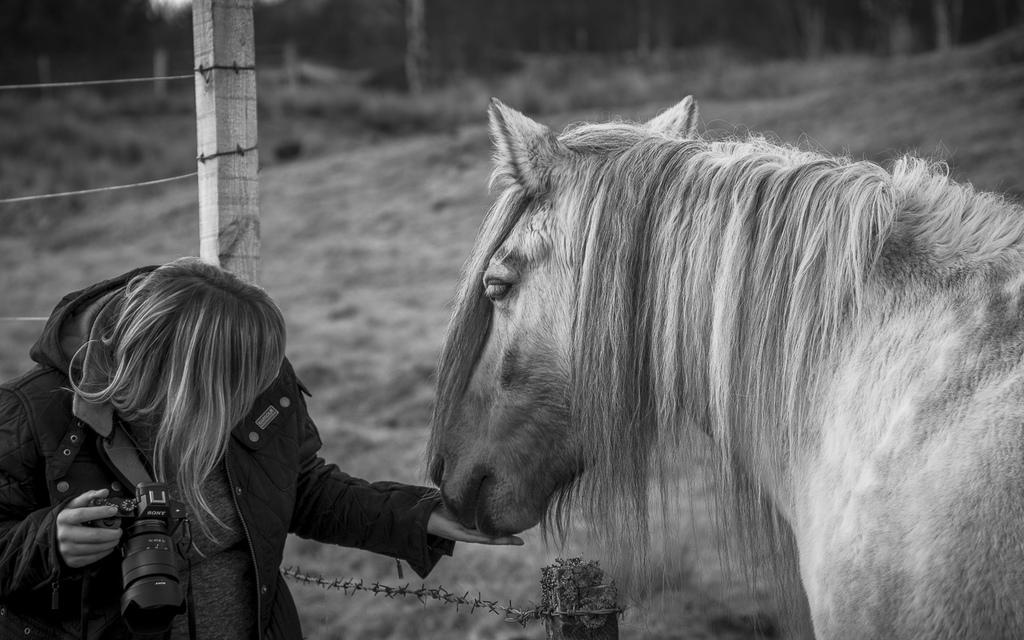What animal is on the right side of the image? There is a horse on the right side of the image. What is the woman in the image doing? The woman is holding a camera in her hands. Where is the woman located in the image? The woman is on the left side of the image. What can be seen in the background of the image? There is a fence visible in the background of the image. What type of coal is being used to support the woman's knee in the image? There is no coal or support for the woman's knee in the image; she is simply holding a camera. Can you tell me how many porters are assisting the woman in the image? There are no porters present in the image; the woman is alone with her camera. 